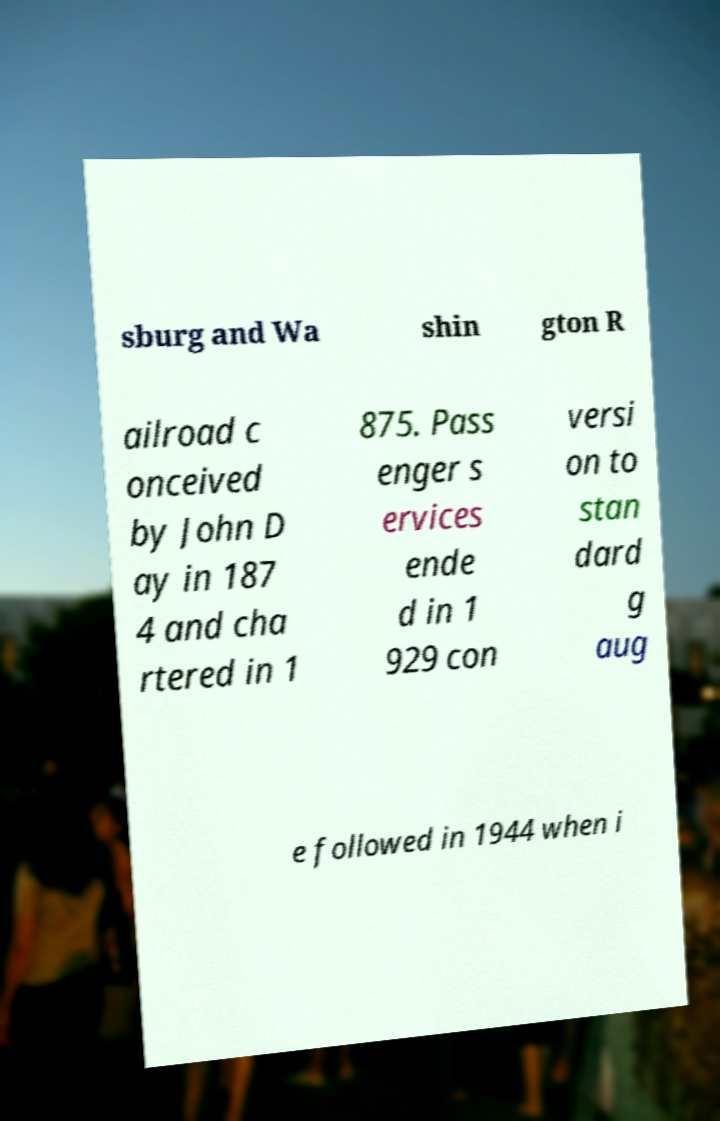What messages or text are displayed in this image? I need them in a readable, typed format. sburg and Wa shin gton R ailroad c onceived by John D ay in 187 4 and cha rtered in 1 875. Pass enger s ervices ende d in 1 929 con versi on to stan dard g aug e followed in 1944 when i 